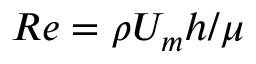Convert formula to latex. <formula><loc_0><loc_0><loc_500><loc_500>R e = \rho U _ { m } h / \mu</formula> 